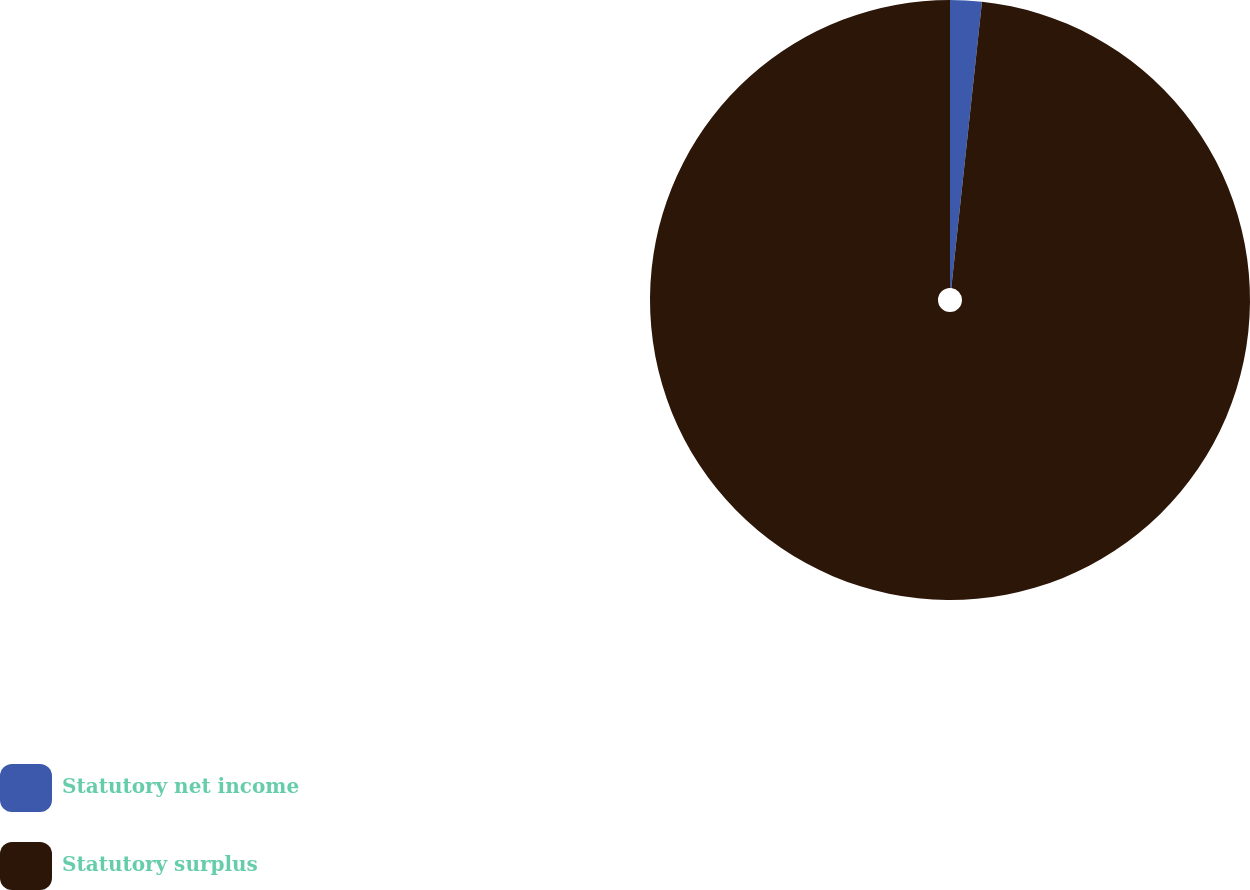<chart> <loc_0><loc_0><loc_500><loc_500><pie_chart><fcel>Statutory net income<fcel>Statutory surplus<nl><fcel>1.7%<fcel>98.3%<nl></chart> 